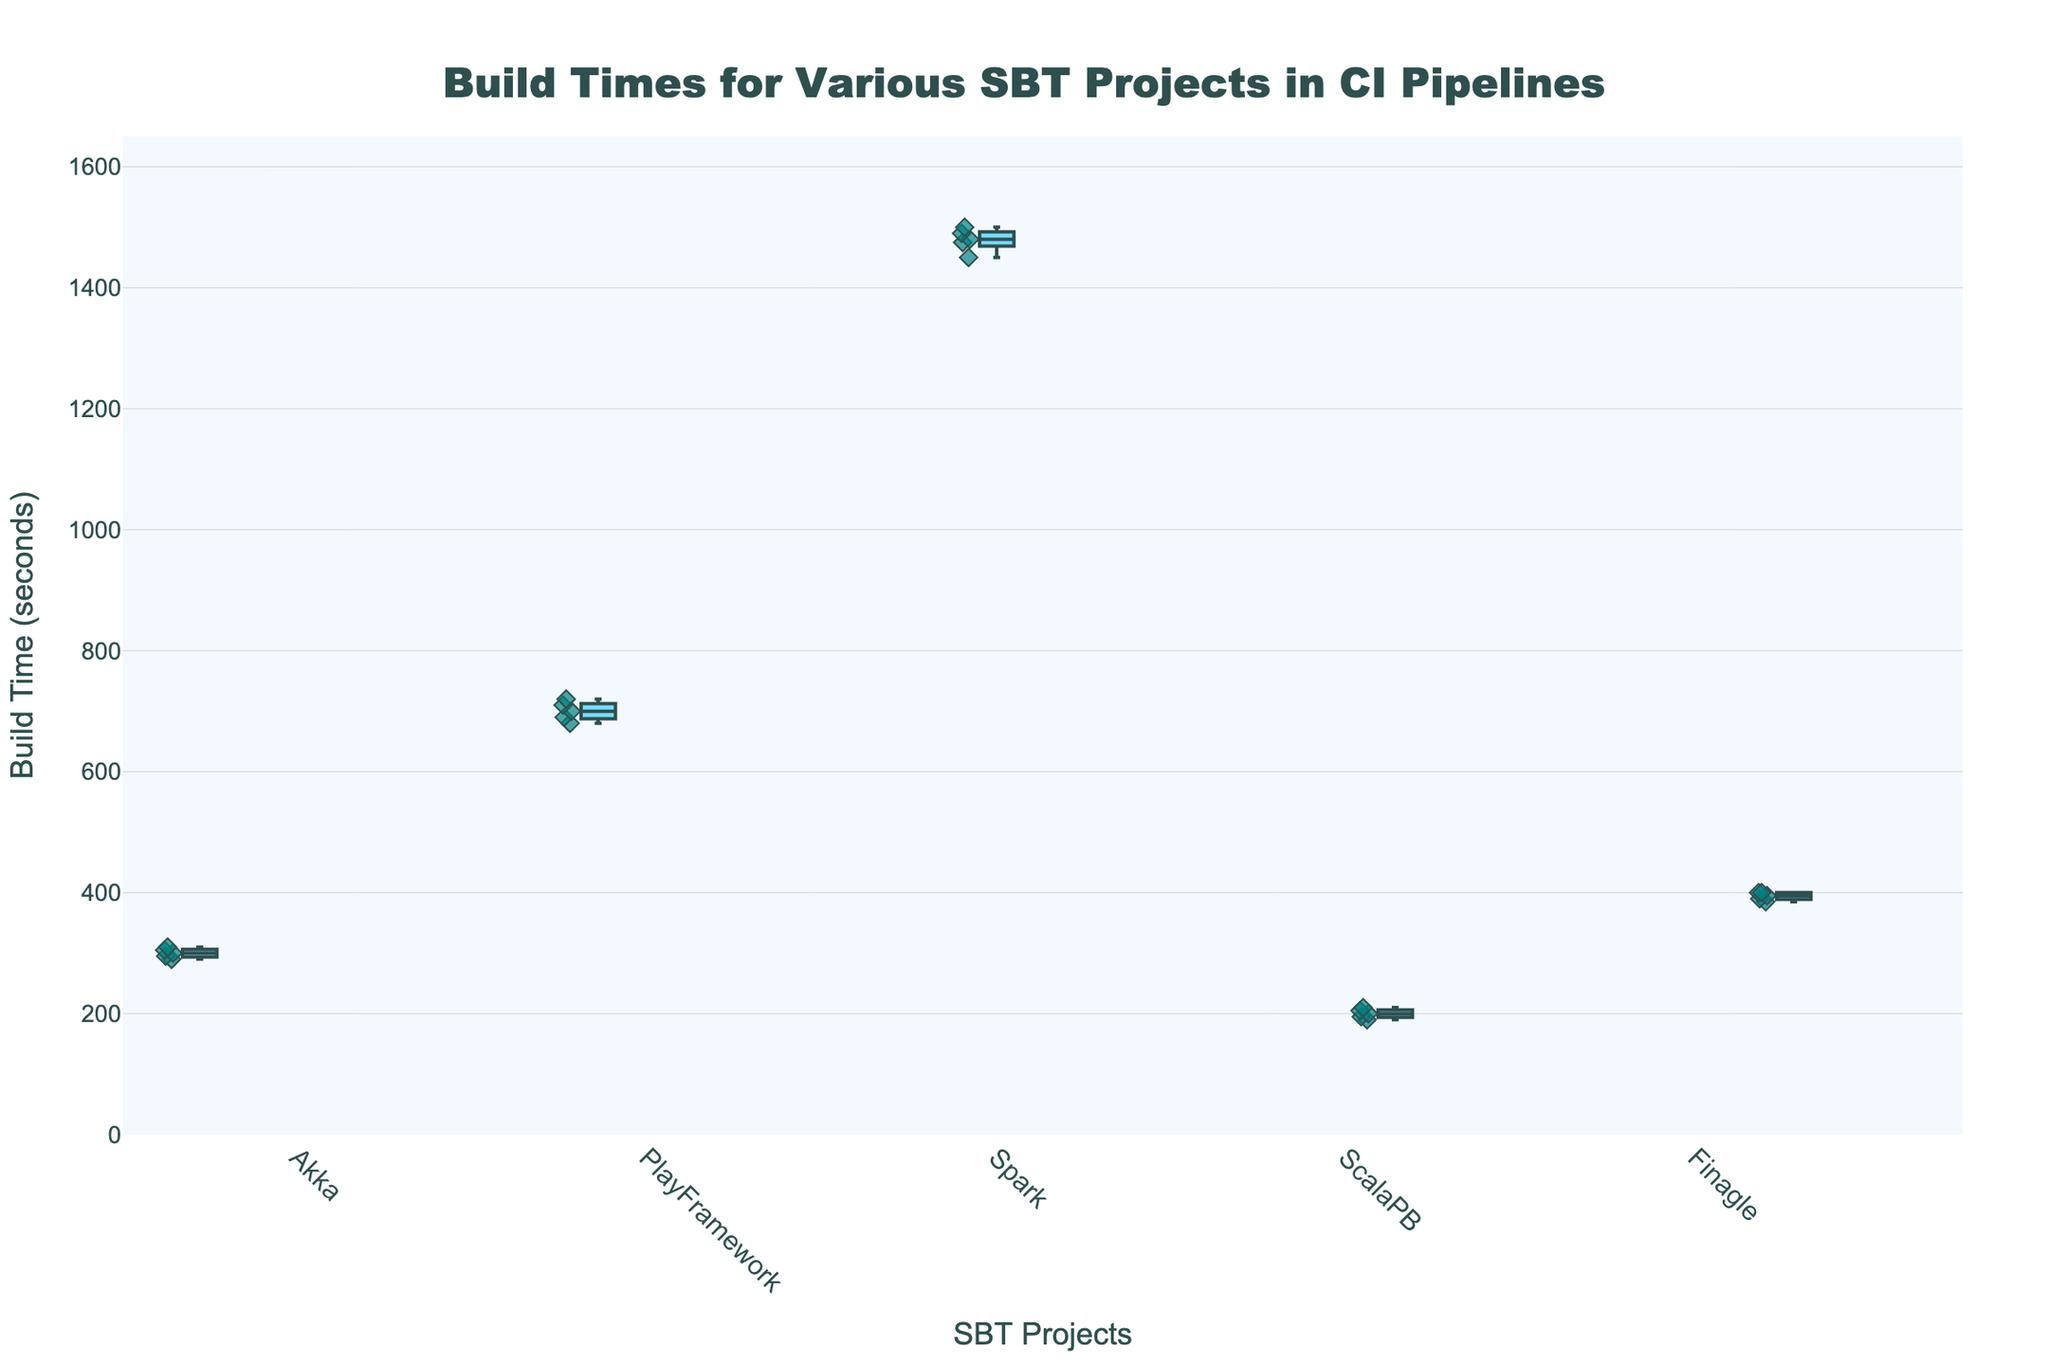What's the title of the figure? The title is located at the top of the figure and serves as a descriptive summary of what the data represents.
Answer: Build Times for Various SBT Projects in CI Pipelines What are the names of the SBT projects displayed on the x-axis? The projects' names are shown on the x-axis at the bottom of the figure, each representing a category.
Answer: Akka, PlayFramework, Spark, ScalaPB, Finagle Which project has the longest median build time? By looking at the median line within the boxes, the project with the highest median build time can be identified.
Answer: Spark What is the range of build times for the Finagle project? The range is determined by the minimum and maximum points shown by the whiskers of the box plot for the Finagle project.
Answer: 385 to 400 seconds How does the variability in build times for Spark compare to ScalaPB? Variability can be assessed by comparing the interquartile range (the width of the boxes) and the spread of the whiskers for Spark and ScalaPB.
Answer: Spark has more variability Which project has the smallest interquartile range (IQR)? The IQR is represented by the width of the box. The project with the smallest box has the smallest IQR.
Answer: Finagle What is the median build time for the PlayFramework project? The median is indicated by the line inside the box for the PlayFramework project.
Answer: 700 seconds Are there any potential outliers in the build times? If so, for which projects? Outliers are typically indicated by points that lie outside the whiskers of the box plot. Identify them visually.
Answer: No visible outliers What's the difference in median build times between Akka and PlayFramework? Subtract the median build time of Akka from the median build time of PlayFramework by looking at the median lines within each box.
Answer: Approximately 400 seconds How do the build times for the Akka project compare with those of the Finagle project? Compare both the medians and the spread (range) of the build times between the Akka and Finagle projects.
Answer: Akka has a higher median build time and slightly more variability 